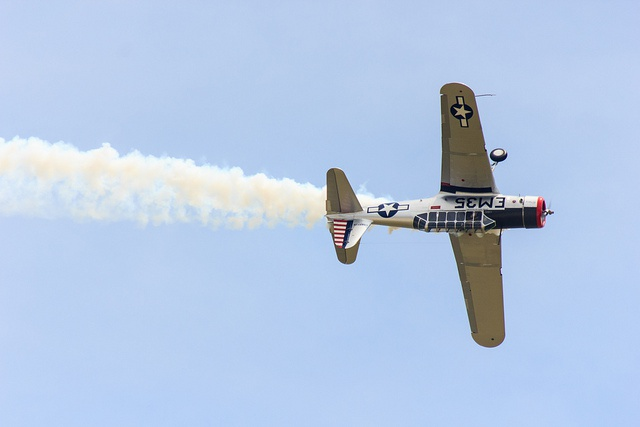Describe the objects in this image and their specific colors. I can see a airplane in lavender, gray, black, and lightgray tones in this image. 